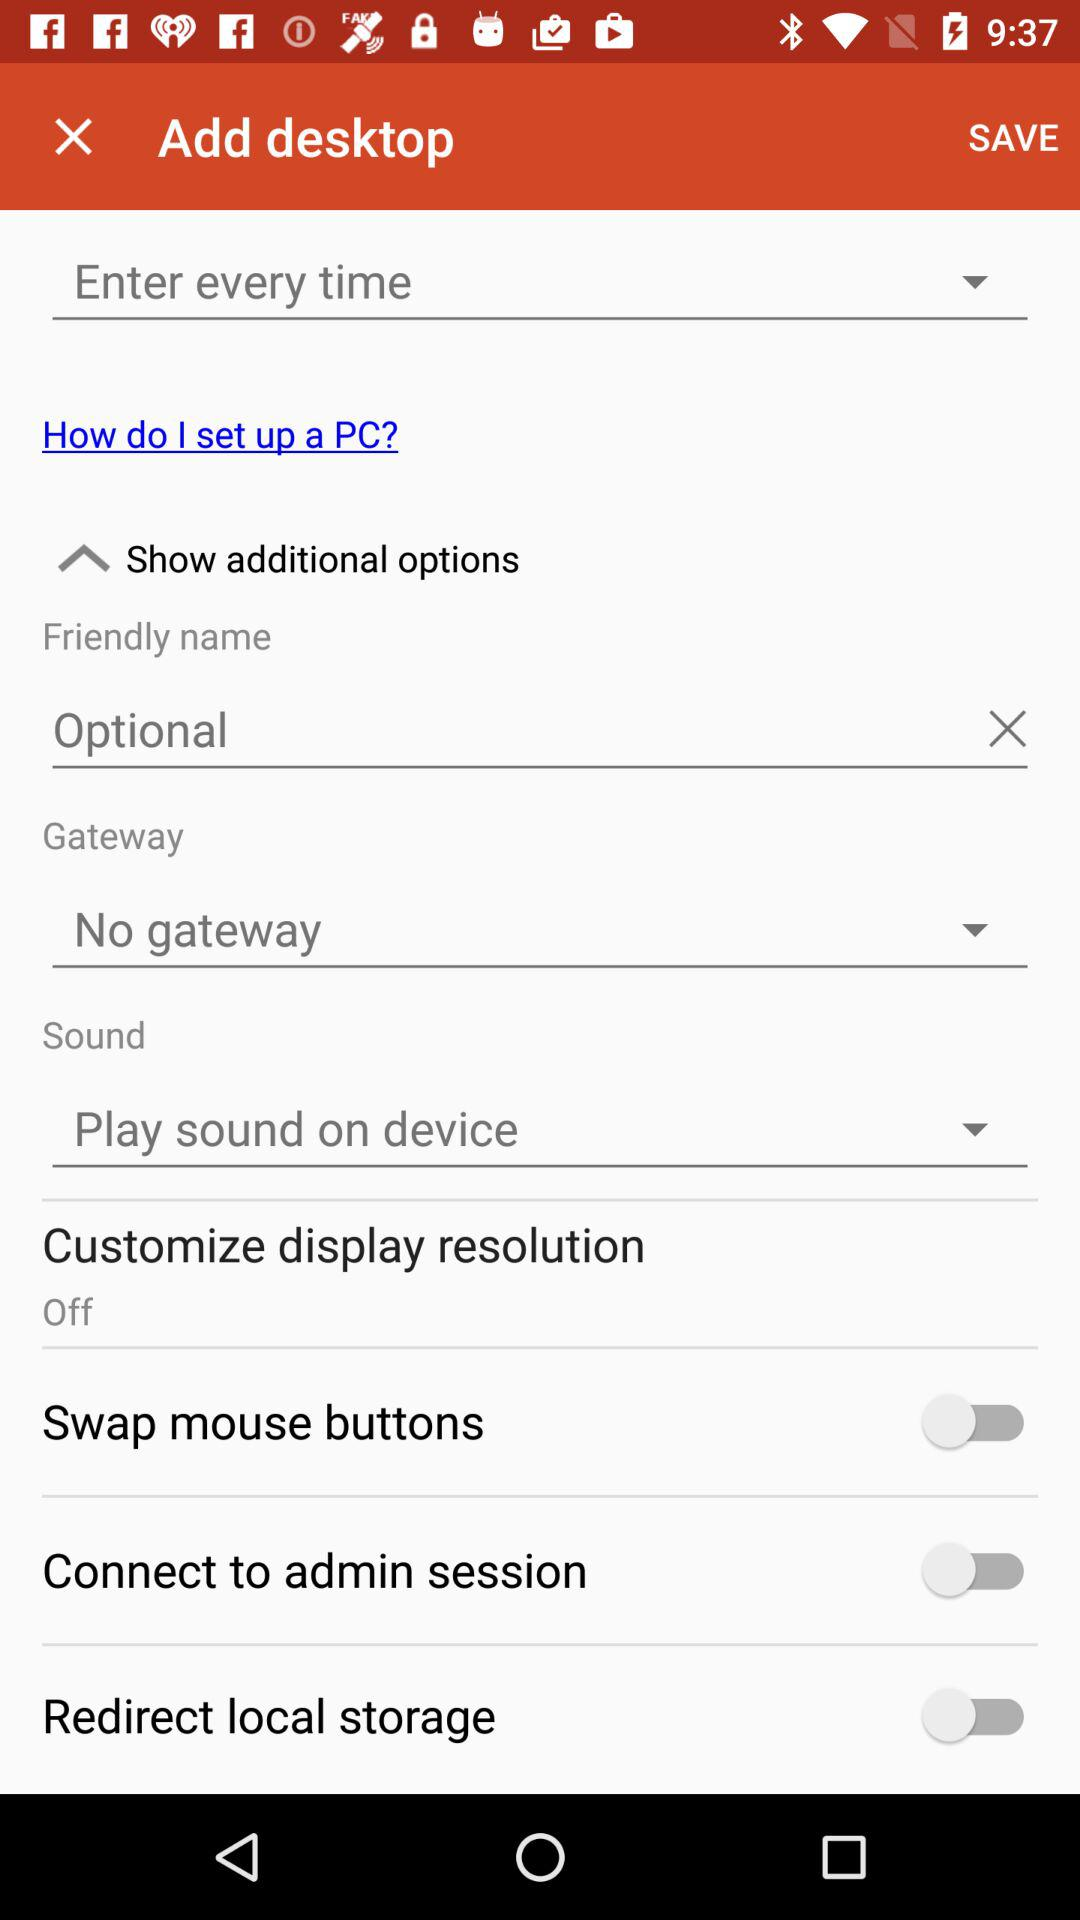What is the status of the "Customize display resolution"? The "Customize display resolution" is turned off. 